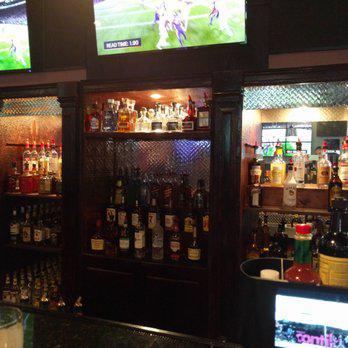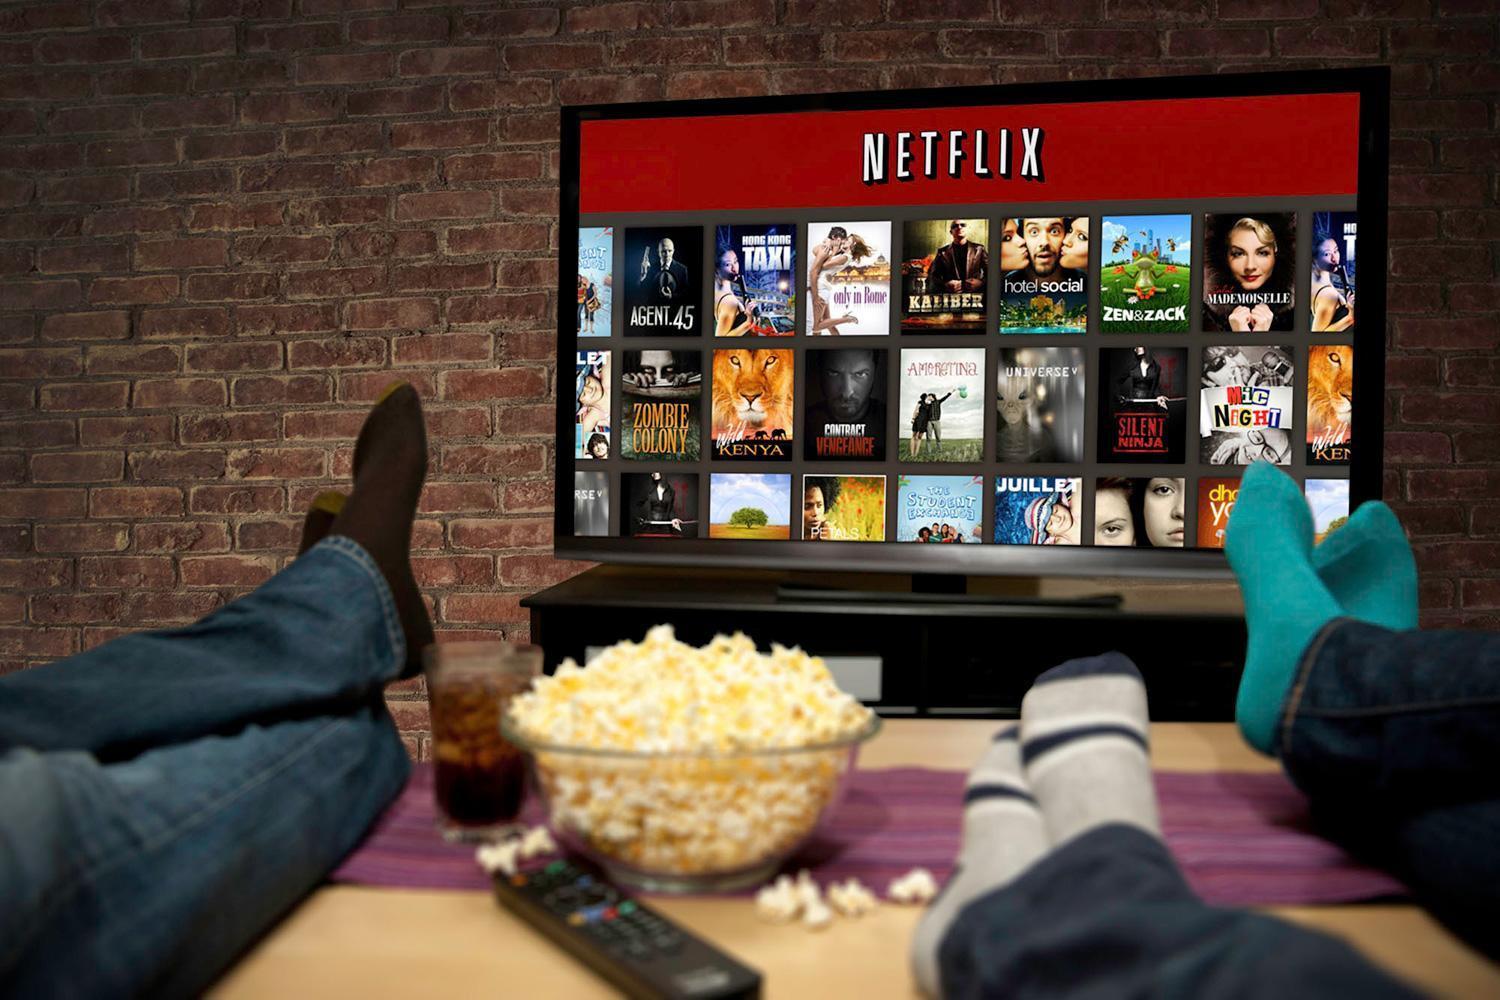The first image is the image on the left, the second image is the image on the right. Considering the images on both sides, is "Left image shows people in a bar with a row of screens overhead." valid? Answer yes or no. No. 